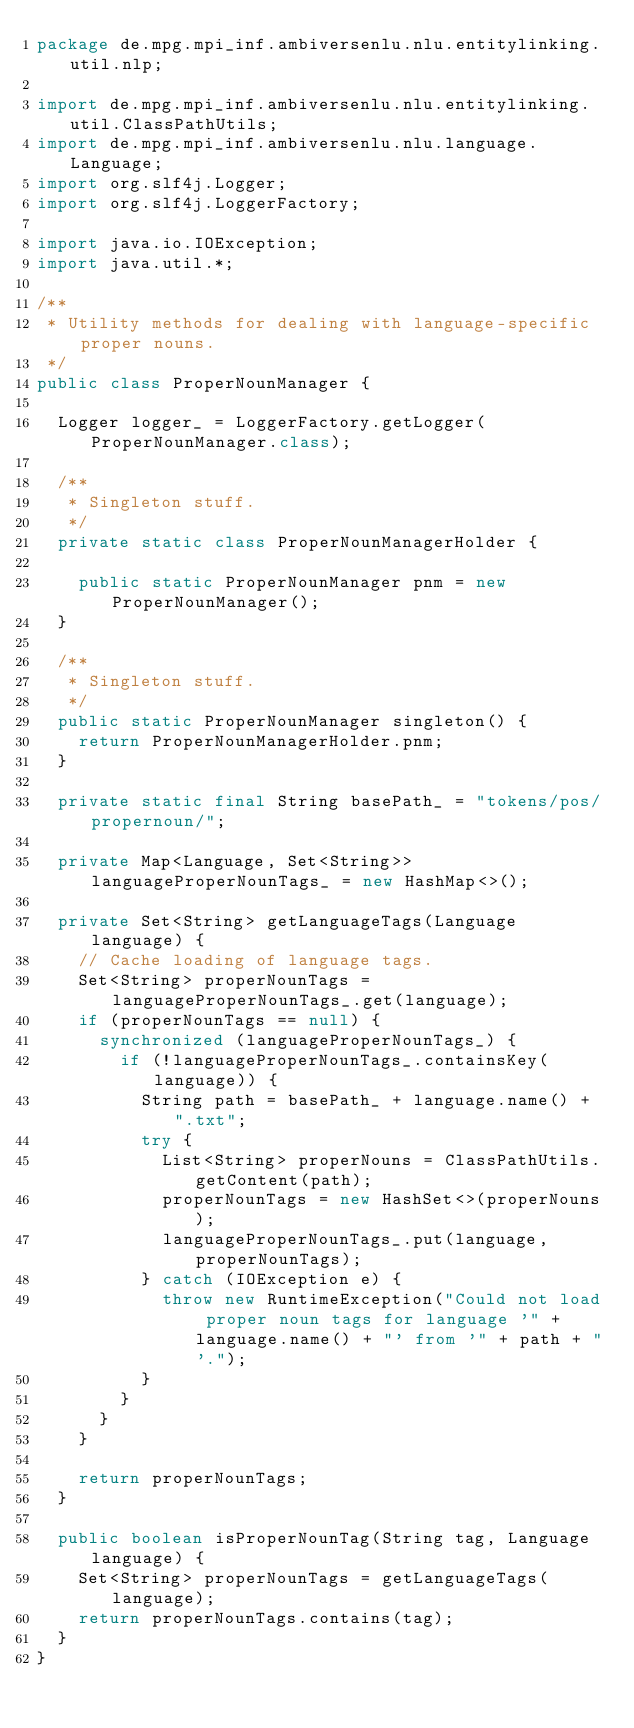Convert code to text. <code><loc_0><loc_0><loc_500><loc_500><_Java_>package de.mpg.mpi_inf.ambiversenlu.nlu.entitylinking.util.nlp;

import de.mpg.mpi_inf.ambiversenlu.nlu.entitylinking.util.ClassPathUtils;
import de.mpg.mpi_inf.ambiversenlu.nlu.language.Language;
import org.slf4j.Logger;
import org.slf4j.LoggerFactory;

import java.io.IOException;
import java.util.*;

/**
 * Utility methods for dealing with language-specific proper nouns.
 */
public class ProperNounManager {

  Logger logger_ = LoggerFactory.getLogger(ProperNounManager.class);

  /**
   * Singleton stuff.
   */
  private static class ProperNounManagerHolder {

    public static ProperNounManager pnm = new ProperNounManager();
  }

  /**
   * Singleton stuff.
   */
  public static ProperNounManager singleton() {
    return ProperNounManagerHolder.pnm;
  }

  private static final String basePath_ = "tokens/pos/propernoun/";

  private Map<Language, Set<String>> languageProperNounTags_ = new HashMap<>();

  private Set<String> getLanguageTags(Language language) {
    // Cache loading of language tags.
    Set<String> properNounTags = languageProperNounTags_.get(language);
    if (properNounTags == null) {
      synchronized (languageProperNounTags_) {
        if (!languageProperNounTags_.containsKey(language)) {
          String path = basePath_ + language.name() + ".txt";
          try {
            List<String> properNouns = ClassPathUtils.getContent(path);
            properNounTags = new HashSet<>(properNouns);
            languageProperNounTags_.put(language, properNounTags);
          } catch (IOException e) {
            throw new RuntimeException("Could not load proper noun tags for language '" + language.name() + "' from '" + path + "'.");
          }
        }
      }
    }

    return properNounTags;
  }

  public boolean isProperNounTag(String tag, Language language) {
    Set<String> properNounTags = getLanguageTags(language);
    return properNounTags.contains(tag);
  }
}
</code> 